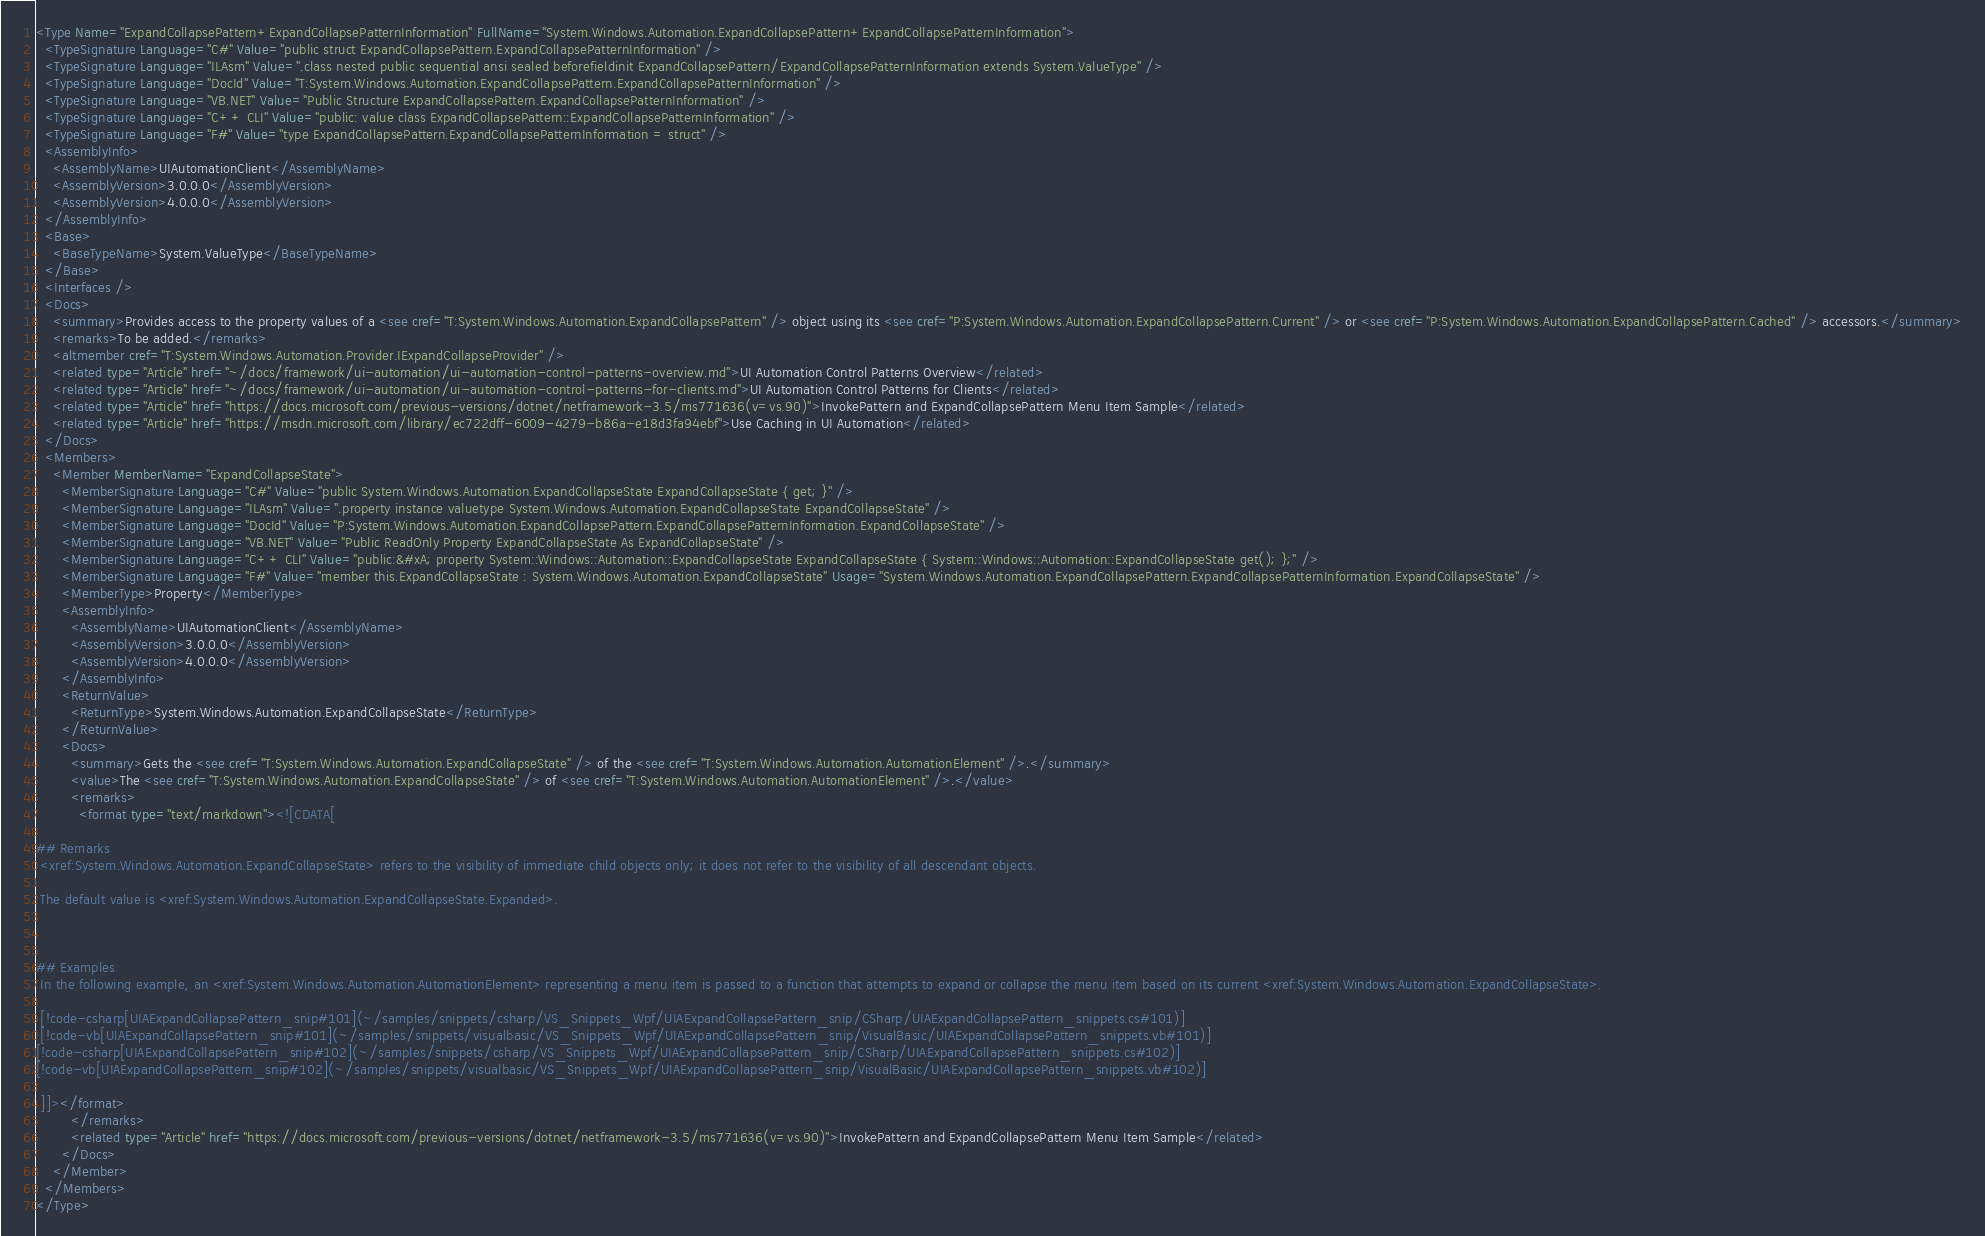<code> <loc_0><loc_0><loc_500><loc_500><_XML_><Type Name="ExpandCollapsePattern+ExpandCollapsePatternInformation" FullName="System.Windows.Automation.ExpandCollapsePattern+ExpandCollapsePatternInformation">
  <TypeSignature Language="C#" Value="public struct ExpandCollapsePattern.ExpandCollapsePatternInformation" />
  <TypeSignature Language="ILAsm" Value=".class nested public sequential ansi sealed beforefieldinit ExpandCollapsePattern/ExpandCollapsePatternInformation extends System.ValueType" />
  <TypeSignature Language="DocId" Value="T:System.Windows.Automation.ExpandCollapsePattern.ExpandCollapsePatternInformation" />
  <TypeSignature Language="VB.NET" Value="Public Structure ExpandCollapsePattern.ExpandCollapsePatternInformation" />
  <TypeSignature Language="C++ CLI" Value="public: value class ExpandCollapsePattern::ExpandCollapsePatternInformation" />
  <TypeSignature Language="F#" Value="type ExpandCollapsePattern.ExpandCollapsePatternInformation = struct" />
  <AssemblyInfo>
    <AssemblyName>UIAutomationClient</AssemblyName>
    <AssemblyVersion>3.0.0.0</AssemblyVersion>
    <AssemblyVersion>4.0.0.0</AssemblyVersion>
  </AssemblyInfo>
  <Base>
    <BaseTypeName>System.ValueType</BaseTypeName>
  </Base>
  <Interfaces />
  <Docs>
    <summary>Provides access to the property values of a <see cref="T:System.Windows.Automation.ExpandCollapsePattern" /> object using its <see cref="P:System.Windows.Automation.ExpandCollapsePattern.Current" /> or <see cref="P:System.Windows.Automation.ExpandCollapsePattern.Cached" /> accessors.</summary>
    <remarks>To be added.</remarks>
    <altmember cref="T:System.Windows.Automation.Provider.IExpandCollapseProvider" />
    <related type="Article" href="~/docs/framework/ui-automation/ui-automation-control-patterns-overview.md">UI Automation Control Patterns Overview</related>
    <related type="Article" href="~/docs/framework/ui-automation/ui-automation-control-patterns-for-clients.md">UI Automation Control Patterns for Clients</related>
    <related type="Article" href="https://docs.microsoft.com/previous-versions/dotnet/netframework-3.5/ms771636(v=vs.90)">InvokePattern and ExpandCollapsePattern Menu Item Sample</related>
    <related type="Article" href="https://msdn.microsoft.com/library/ec722dff-6009-4279-b86a-e18d3fa94ebf">Use Caching in UI Automation</related>
  </Docs>
  <Members>
    <Member MemberName="ExpandCollapseState">
      <MemberSignature Language="C#" Value="public System.Windows.Automation.ExpandCollapseState ExpandCollapseState { get; }" />
      <MemberSignature Language="ILAsm" Value=".property instance valuetype System.Windows.Automation.ExpandCollapseState ExpandCollapseState" />
      <MemberSignature Language="DocId" Value="P:System.Windows.Automation.ExpandCollapsePattern.ExpandCollapsePatternInformation.ExpandCollapseState" />
      <MemberSignature Language="VB.NET" Value="Public ReadOnly Property ExpandCollapseState As ExpandCollapseState" />
      <MemberSignature Language="C++ CLI" Value="public:&#xA; property System::Windows::Automation::ExpandCollapseState ExpandCollapseState { System::Windows::Automation::ExpandCollapseState get(); };" />
      <MemberSignature Language="F#" Value="member this.ExpandCollapseState : System.Windows.Automation.ExpandCollapseState" Usage="System.Windows.Automation.ExpandCollapsePattern.ExpandCollapsePatternInformation.ExpandCollapseState" />
      <MemberType>Property</MemberType>
      <AssemblyInfo>
        <AssemblyName>UIAutomationClient</AssemblyName>
        <AssemblyVersion>3.0.0.0</AssemblyVersion>
        <AssemblyVersion>4.0.0.0</AssemblyVersion>
      </AssemblyInfo>
      <ReturnValue>
        <ReturnType>System.Windows.Automation.ExpandCollapseState</ReturnType>
      </ReturnValue>
      <Docs>
        <summary>Gets the <see cref="T:System.Windows.Automation.ExpandCollapseState" /> of the <see cref="T:System.Windows.Automation.AutomationElement" />.</summary>
        <value>The <see cref="T:System.Windows.Automation.ExpandCollapseState" /> of <see cref="T:System.Windows.Automation.AutomationElement" />.</value>
        <remarks>
          <format type="text/markdown"><![CDATA[  
  
## Remarks  
 <xref:System.Windows.Automation.ExpandCollapseState> refers to the visibility of immediate child objects only; it does not refer to the visibility of all descendant objects.  
  
 The default value is <xref:System.Windows.Automation.ExpandCollapseState.Expanded>.  
  
   
  
## Examples  
 In the following example, an <xref:System.Windows.Automation.AutomationElement> representing a menu item is passed to a function that attempts to expand or collapse the menu item based on its current <xref:System.Windows.Automation.ExpandCollapseState>.  
  
 [!code-csharp[UIAExpandCollapsePattern_snip#101](~/samples/snippets/csharp/VS_Snippets_Wpf/UIAExpandCollapsePattern_snip/CSharp/UIAExpandCollapsePattern_snippets.cs#101)]
 [!code-vb[UIAExpandCollapsePattern_snip#101](~/samples/snippets/visualbasic/VS_Snippets_Wpf/UIAExpandCollapsePattern_snip/VisualBasic/UIAExpandCollapsePattern_snippets.vb#101)]  
[!code-csharp[UIAExpandCollapsePattern_snip#102](~/samples/snippets/csharp/VS_Snippets_Wpf/UIAExpandCollapsePattern_snip/CSharp/UIAExpandCollapsePattern_snippets.cs#102)]
[!code-vb[UIAExpandCollapsePattern_snip#102](~/samples/snippets/visualbasic/VS_Snippets_Wpf/UIAExpandCollapsePattern_snip/VisualBasic/UIAExpandCollapsePattern_snippets.vb#102)]  
  
 ]]></format>
        </remarks>
        <related type="Article" href="https://docs.microsoft.com/previous-versions/dotnet/netframework-3.5/ms771636(v=vs.90)">InvokePattern and ExpandCollapsePattern Menu Item Sample</related>
      </Docs>
    </Member>
  </Members>
</Type>
</code> 